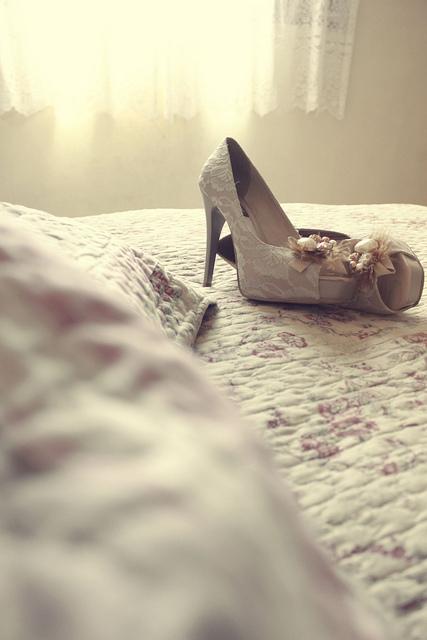Is the shoe on the ground?
Write a very short answer. No. Is the photo monochromatic?
Write a very short answer. Yes. How large is the heel on the shoe?
Be succinct. 3 inches. 